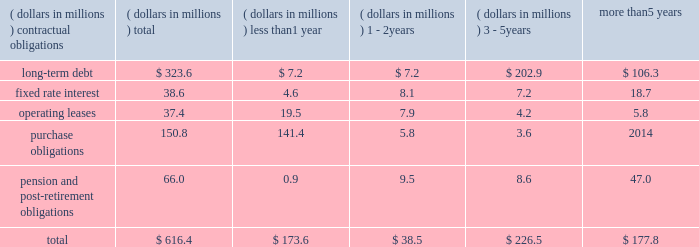In november 2016 , we issued $ 45 million of fixed rate term notes in two tranches to two insurance companies .
Principal payments commence in 2023 and 2028 and the notes mature in 2029 and 2034 , respectively .
The notes carry interest rates of 2.87 and 3.10 , respectively .
We used proceeds of the notes to pay down borrowings under our revolving credit facility .
In january 2015 , we issued $ 75 million of fixed rate term notes to an insurance company .
Principal payments commence in 2020 and the notes mature in 2030 .
The notes carry an interest rate of 3.52 percent .
We used proceeds of the notes to pay down borrowings under our revolving credit facility .
At december 31 , 2016 , we had available borrowing capacity of $ 310.8 million under this facility .
We believe that the combination of cash , available borrowing capacity and operating cash flow will provide sufficient funds to finance our existing operations for the foreseeable future .
Our total debt increased to $ 323.6 million at december 31 , 2016 compared with $ 249.0 million at december 31 , 2015 , as our cash flows generated in the u.s were more than offset by our share repurchase activity and our purchase of aquasana .
As a result , our leverage , as measured by the ratio of total debt to total capitalization , was 17.6 percent at the end of 2016 compared with 14.7 percent at the end of 2015 .
Our u.s .
Pension plan continues to meet all funding requirements under erisa regulations .
We were not required to make a contribution to our pension plan in 2016 but made a voluntary $ 30 million contribution due to escalating pension benefit guaranty corporation insurance premiums .
We forecast that we will not be required to make a contribution to the plan in 2017 and we do not plan to make any voluntary contributions in 2017 .
For further information on our pension plans , see note 10 of the notes to consolidated financial statements .
During 2016 , our board of directors authorized the purchase of an additional 3000000 shares of our common stock .
In 2016 , we repurchased 3273109 shares at an average price of $ 41.30 per share and a total cost of $ 135.2 million .
A total of 4906403 shares remained on the existing repurchase authorization at december 31 , 2016 .
Depending on factors such as stock price , working capital requirements and alternative investment opportunities , such as acquisitions , we expect to spend approximately $ 135 million on share repurchase activity in 2017 using a 10b5-1 repurchase plan .
In addition , we may opportunistically repurchase an additional $ 65 million of our shares in 2017 .
We have paid dividends for 77 consecutive years with payments increasing each of the last 25 years .
We paid dividends of $ 0.48 per share in 2016 compared with $ 0.38 per share in 2015 .
In january 2017 , we increased our dividend by 17 percent and anticipate paying dividends of $ 0.56 per share in 2017 .
Aggregate contractual obligations a summary of our contractual obligations as of december 31 , 2016 , is as follows: .
As of december 31 , 2016 , our liability for uncertain income tax positions was $ 4.2 million .
Due to the high degree of uncertainty regarding timing of potential future cash flows associated with these liabilities , we are unable to make a reasonably reliable estimate of the amount and period in which these liabilities might be paid .
We utilize blanket purchase orders to communicate expected annual requirements to many of our suppliers .
Requirements under blanket purchase orders generally do not become committed until several weeks prior to our scheduled unit production .
The purchase obligation amount presented above represents the value of commitments that we consider firm .
Recent accounting pronouncements refer to recent accounting pronouncements in note 1 of notes to consolidated financial statements. .
What percentage of total aggregate contractual obligations is due to long term debt? 
Computations: (323.6 / 616.4)
Answer: 0.52498. 